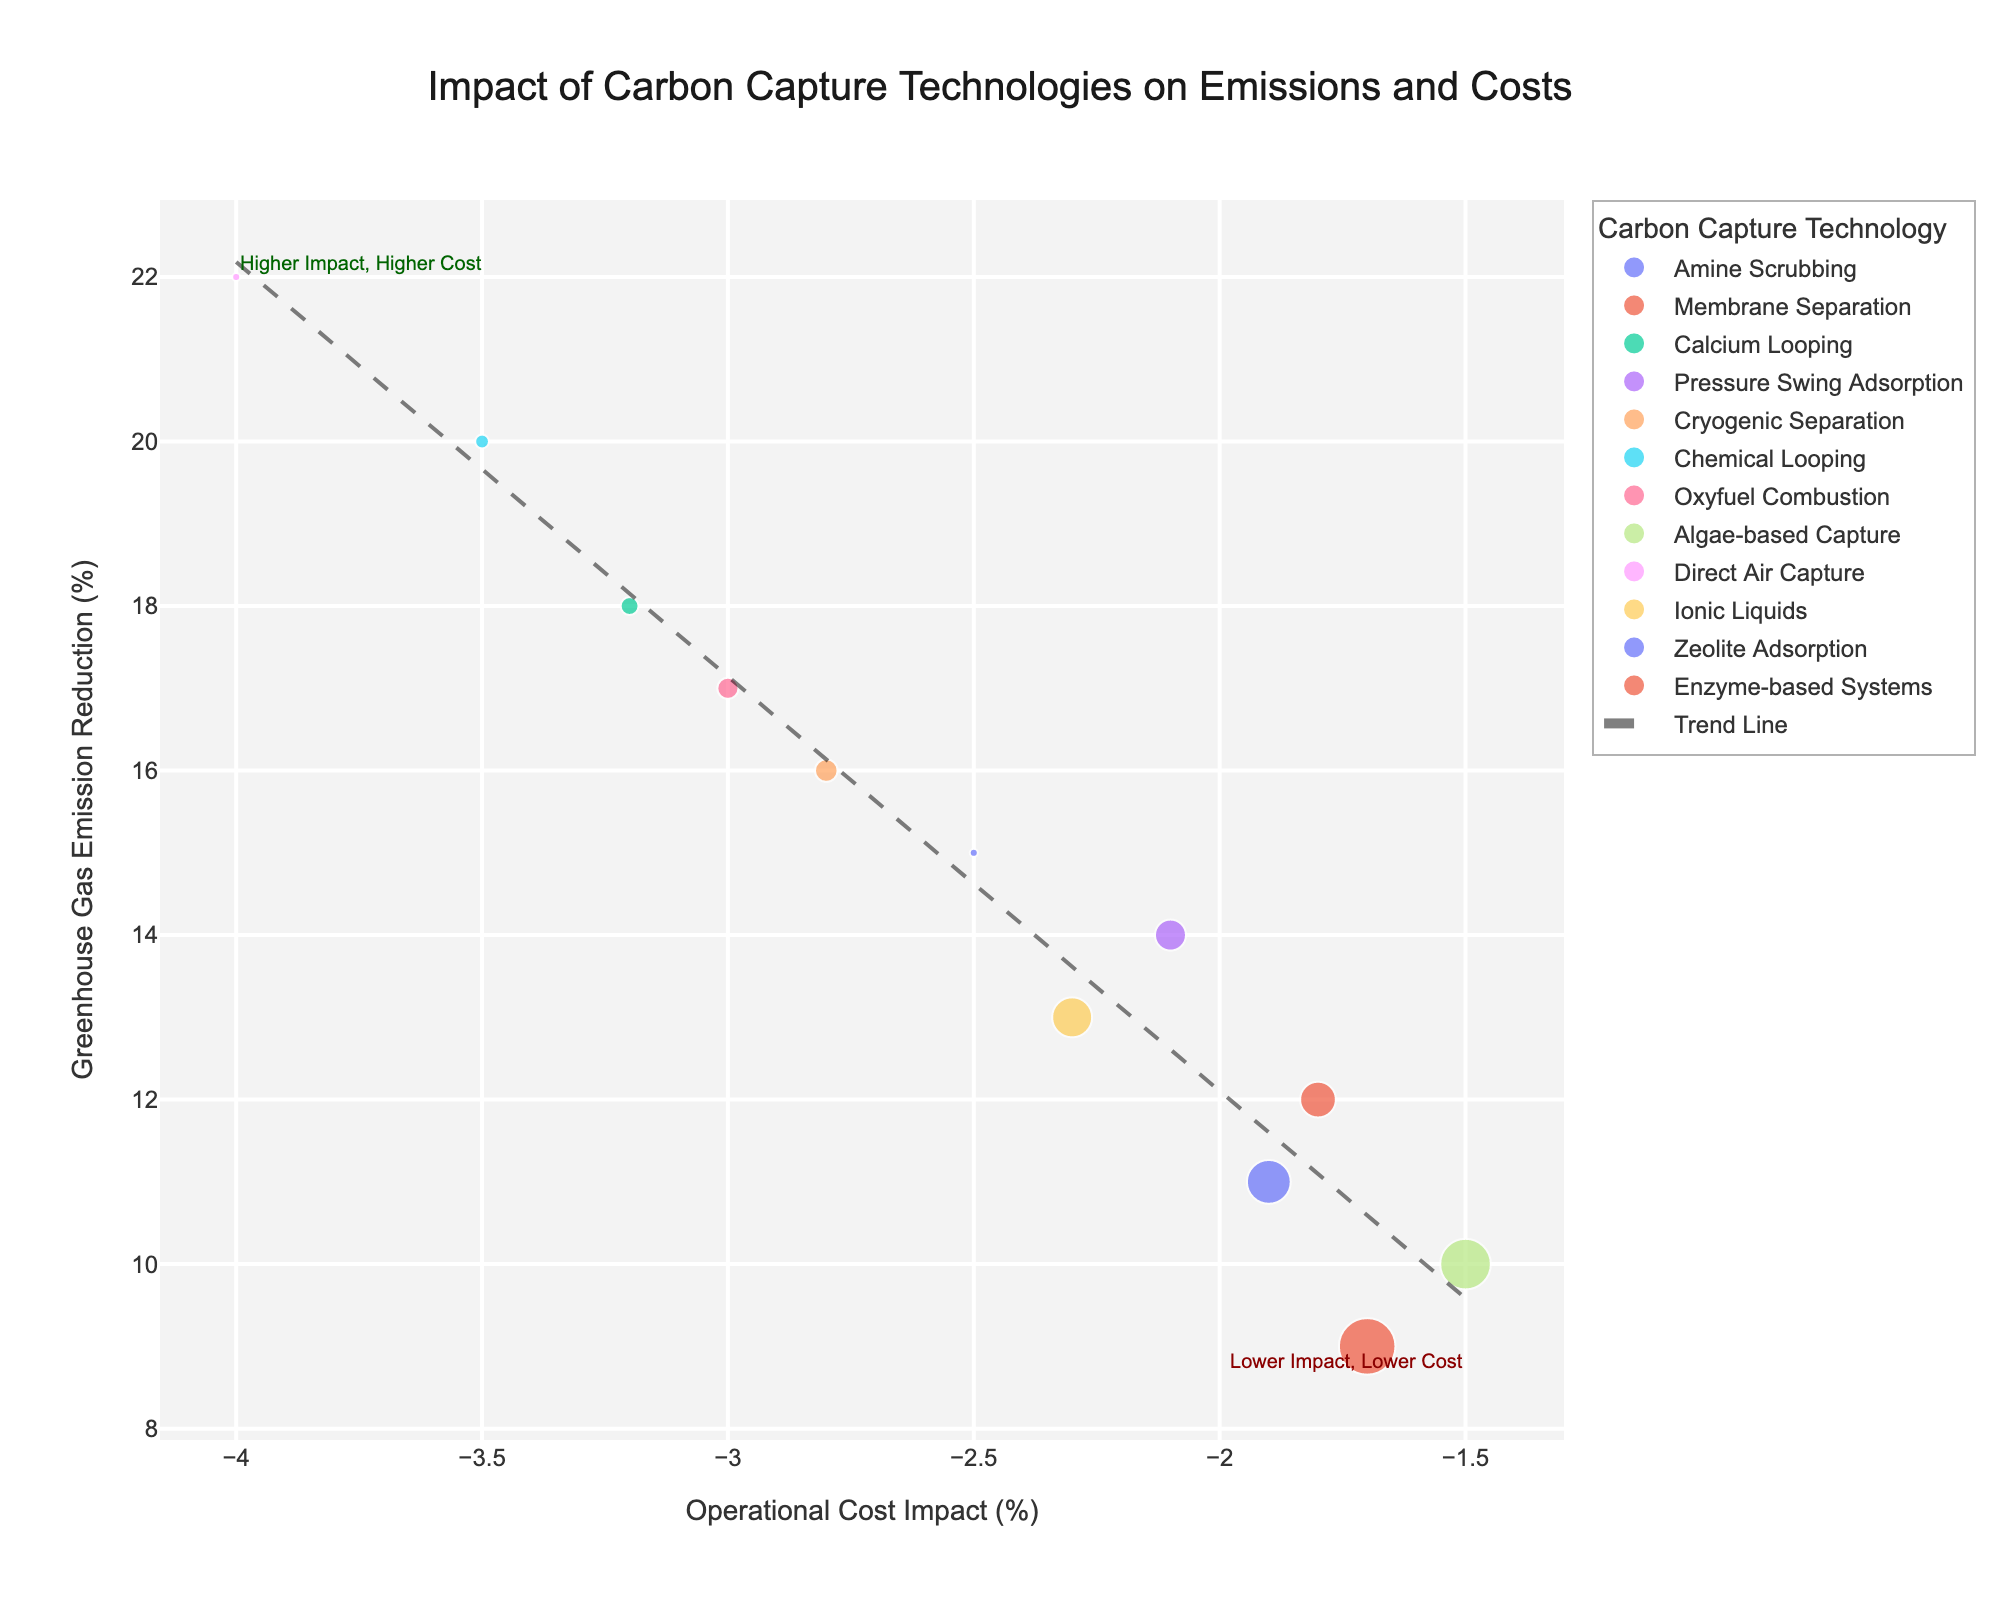What's the title of the figure? The title is given at the top of the figure.
Answer: Impact of Carbon Capture Technologies on Emissions and Costs What are the axes representing in this plot? The x-axis shows the Operational Cost Impact (%) and the y-axis shows the Greenhouse Gas Emission Reduction (%).
Answer: Operational Cost Impact (%) and Greenhouse Gas Emission Reduction (%) How many technologies are compared in this figure? Count the number of unique data points or labels.
Answer: 12 Which technology has the highest greenhouse gas emission reduction? Locate the point with the highest value on the y-axis.
Answer: Direct Air Capture Which technology has the lowest operational cost impact? Identify the point closest to or at the lowest value on the x-axis.
Answer: Direct Air Capture Between Amine Scrubbing and Membrane Separation, which technology has a greater greenhouse gas emission reduction? Compare the y-axis values for Amine Scrubbing (15%) and Membrane Separation (12%).
Answer: Amine Scrubbing What is the trend between cost impact and emission reduction as indicated by the trend line? The slope of the trend line indicates the relationship; if it's positive, both increase together, if negative, one decreases as the other increases. The trend line here slopes downwards.
Answer: Negative correlation Which technology is the least statistically significant based on the size of the points? The smallest point represents the least statistical significance; compare point sizes.
Answer: Enzyme-based Systems Identify the technology that has a 20% reduction in greenhouse gas emissions and describe its cost impact. Locate the point on the y-axis at 20% and find the corresponding value on the x-axis for that point; this relates to Chemical Looping.
Answer: Chemical Looping has an Operational Cost Impact of -3.5% What area of the plot represents technologies that have higher emission reduction but also higher cost impact? Consider the annotations and divisions made in the plot. This would be in the upper left quadrant, as higher cost impact is a more negative value.
Answer: Upper left quadrant 